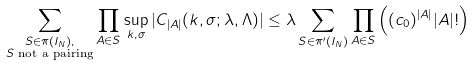Convert formula to latex. <formula><loc_0><loc_0><loc_500><loc_500>& \sum _ { \substack { S \in \pi ( I _ { N } ) , \\ S \text { not a pairing} } } \prod _ { A \in S } \sup _ { k , \sigma } | C _ { | A | } ( k , \sigma ; \lambda , \Lambda ) | \leq \lambda \sum _ { S \in \pi ^ { \prime } ( I _ { N } ) } \prod _ { A \in S } \left ( ( c _ { 0 } ) ^ { | A | } | A | ! \right )</formula> 